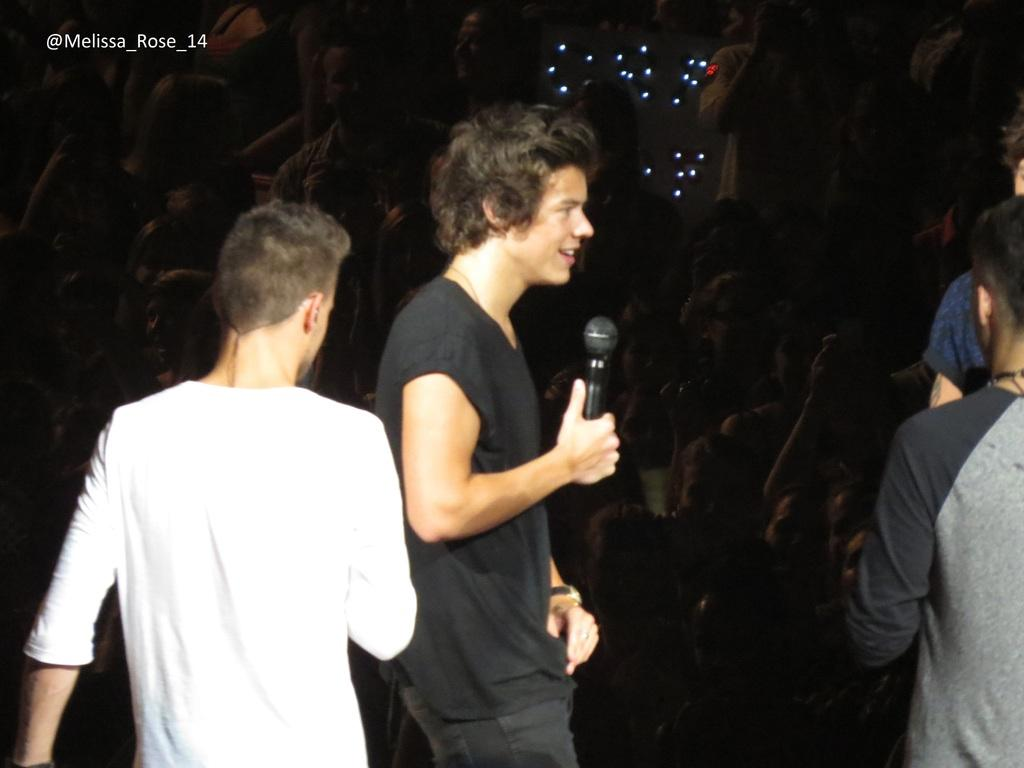How many people are in the image? There are people standing in the image. What is one person doing in the image? One person is holding a microphone. What type of pan can be seen on the ground in the image? There is no pan present in the image. 